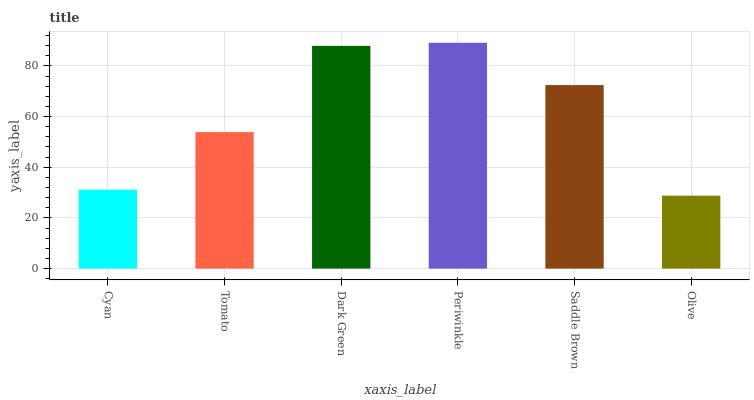Is Olive the minimum?
Answer yes or no. Yes. Is Periwinkle the maximum?
Answer yes or no. Yes. Is Tomato the minimum?
Answer yes or no. No. Is Tomato the maximum?
Answer yes or no. No. Is Tomato greater than Cyan?
Answer yes or no. Yes. Is Cyan less than Tomato?
Answer yes or no. Yes. Is Cyan greater than Tomato?
Answer yes or no. No. Is Tomato less than Cyan?
Answer yes or no. No. Is Saddle Brown the high median?
Answer yes or no. Yes. Is Tomato the low median?
Answer yes or no. Yes. Is Dark Green the high median?
Answer yes or no. No. Is Periwinkle the low median?
Answer yes or no. No. 